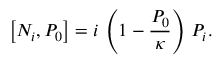<formula> <loc_0><loc_0><loc_500><loc_500>\left [ N _ { i } , P _ { 0 } \right ] = i \, \left ( 1 - { \frac { P _ { 0 } } { \kappa } } \right ) \, P _ { i } .</formula> 